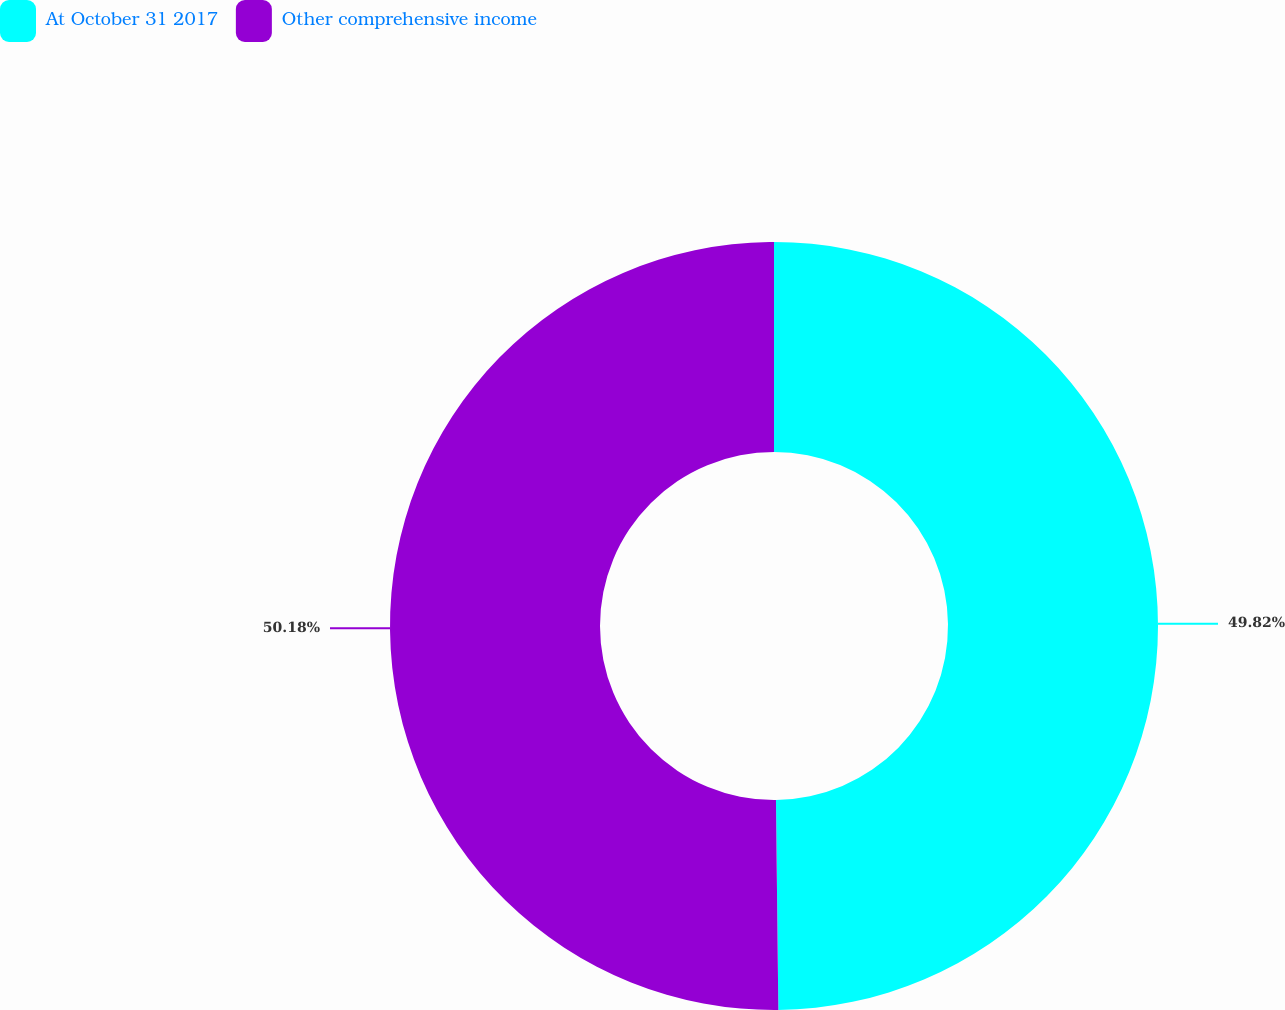Convert chart to OTSL. <chart><loc_0><loc_0><loc_500><loc_500><pie_chart><fcel>At October 31 2017<fcel>Other comprehensive income<nl><fcel>49.82%<fcel>50.18%<nl></chart> 